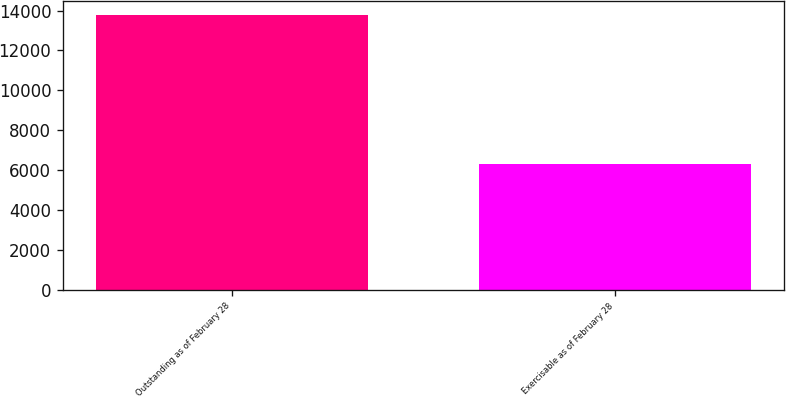Convert chart to OTSL. <chart><loc_0><loc_0><loc_500><loc_500><bar_chart><fcel>Outstanding as of February 28<fcel>Exercisable as of February 28<nl><fcel>13775<fcel>6301<nl></chart> 